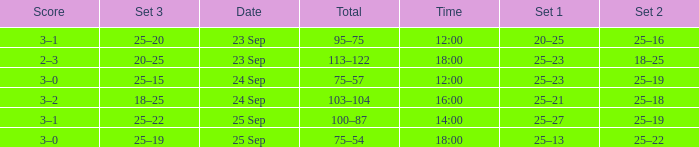What was the score when the time was 14:00? 3–1. Can you parse all the data within this table? {'header': ['Score', 'Set 3', 'Date', 'Total', 'Time', 'Set 1', 'Set 2'], 'rows': [['3–1', '25–20', '23 Sep', '95–75', '12:00', '20–25', '25–16'], ['2–3', '20–25', '23 Sep', '113–122', '18:00', '25–23', '18–25'], ['3–0', '25–15', '24 Sep', '75–57', '12:00', '25–23', '25–19'], ['3–2', '18–25', '24 Sep', '103–104', '16:00', '25–21', '25–18'], ['3–1', '25–22', '25 Sep', '100–87', '14:00', '25–27', '25–19'], ['3–0', '25–19', '25 Sep', '75–54', '18:00', '25–13', '25–22']]} 